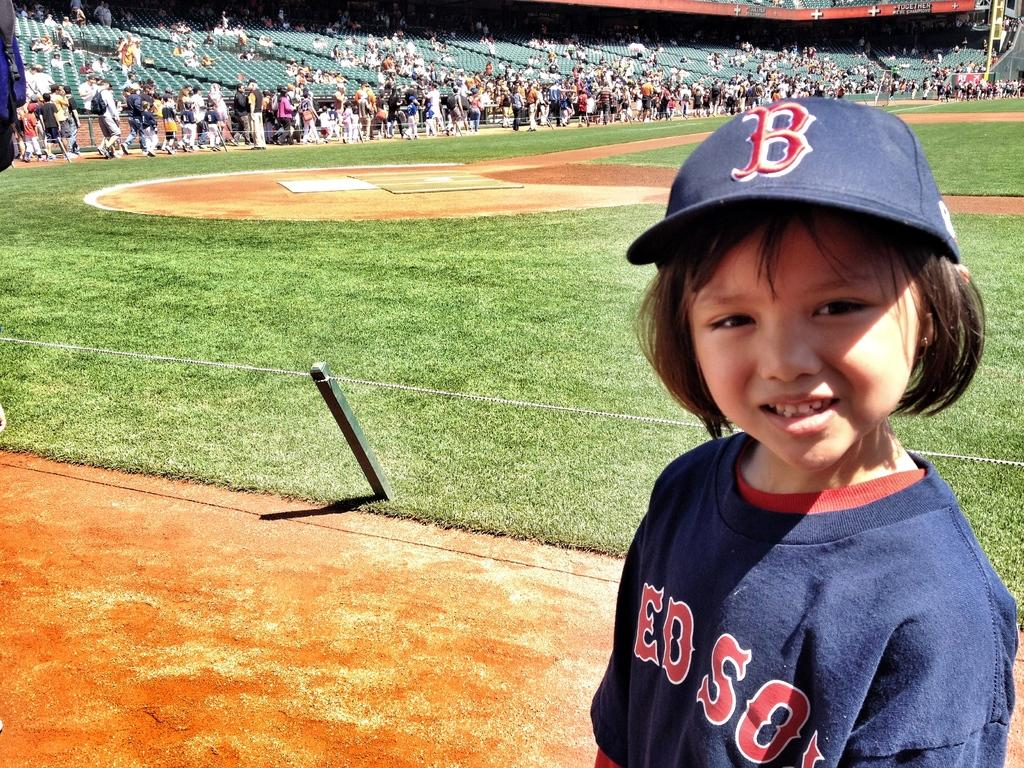<image>
Summarize the visual content of the image. A young child on a baseball diamond wearing RedSox clothing. 